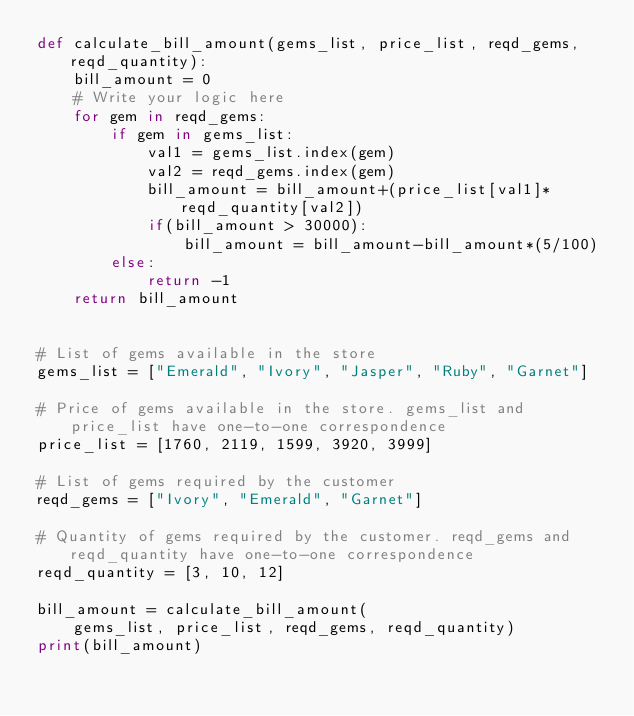Convert code to text. <code><loc_0><loc_0><loc_500><loc_500><_Python_>def calculate_bill_amount(gems_list, price_list, reqd_gems, reqd_quantity):
    bill_amount = 0
    # Write your logic here
    for gem in reqd_gems:
        if gem in gems_list:
            val1 = gems_list.index(gem)
            val2 = reqd_gems.index(gem)
            bill_amount = bill_amount+(price_list[val1]*reqd_quantity[val2])
            if(bill_amount > 30000):
                bill_amount = bill_amount-bill_amount*(5/100)
        else:
            return -1
    return bill_amount


# List of gems available in the store
gems_list = ["Emerald", "Ivory", "Jasper", "Ruby", "Garnet"]

# Price of gems available in the store. gems_list and price_list have one-to-one correspondence
price_list = [1760, 2119, 1599, 3920, 3999]

# List of gems required by the customer
reqd_gems = ["Ivory", "Emerald", "Garnet"]

# Quantity of gems required by the customer. reqd_gems and reqd_quantity have one-to-one correspondence
reqd_quantity = [3, 10, 12]

bill_amount = calculate_bill_amount(
    gems_list, price_list, reqd_gems, reqd_quantity)
print(bill_amount)
</code> 